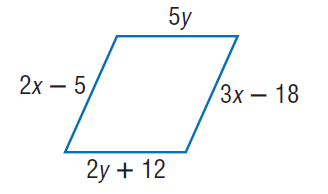Answer the mathemtical geometry problem and directly provide the correct option letter.
Question: Find y so that the quadrilateral is a parallelogram.
Choices: A: 4 B: 8 C: 12 D: 20 A 